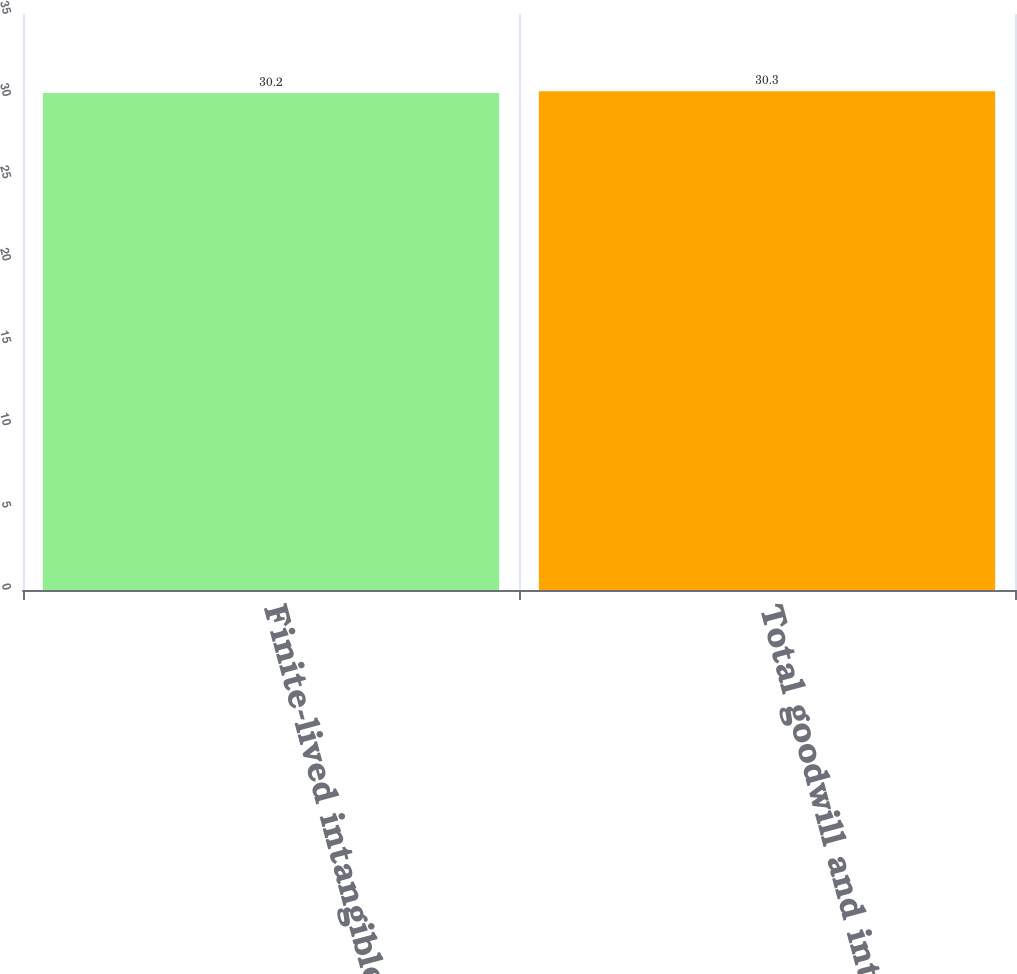<chart> <loc_0><loc_0><loc_500><loc_500><bar_chart><fcel>Finite-lived intangible assets<fcel>Total goodwill and intangible<nl><fcel>30.2<fcel>30.3<nl></chart> 